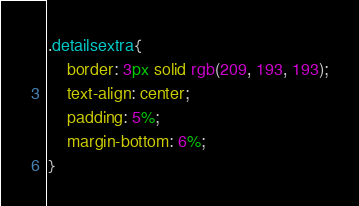<code> <loc_0><loc_0><loc_500><loc_500><_CSS_>.detailsextra{
    border: 3px solid rgb(209, 193, 193);
    text-align: center;
    padding: 5%;
    margin-bottom: 6%;
}</code> 